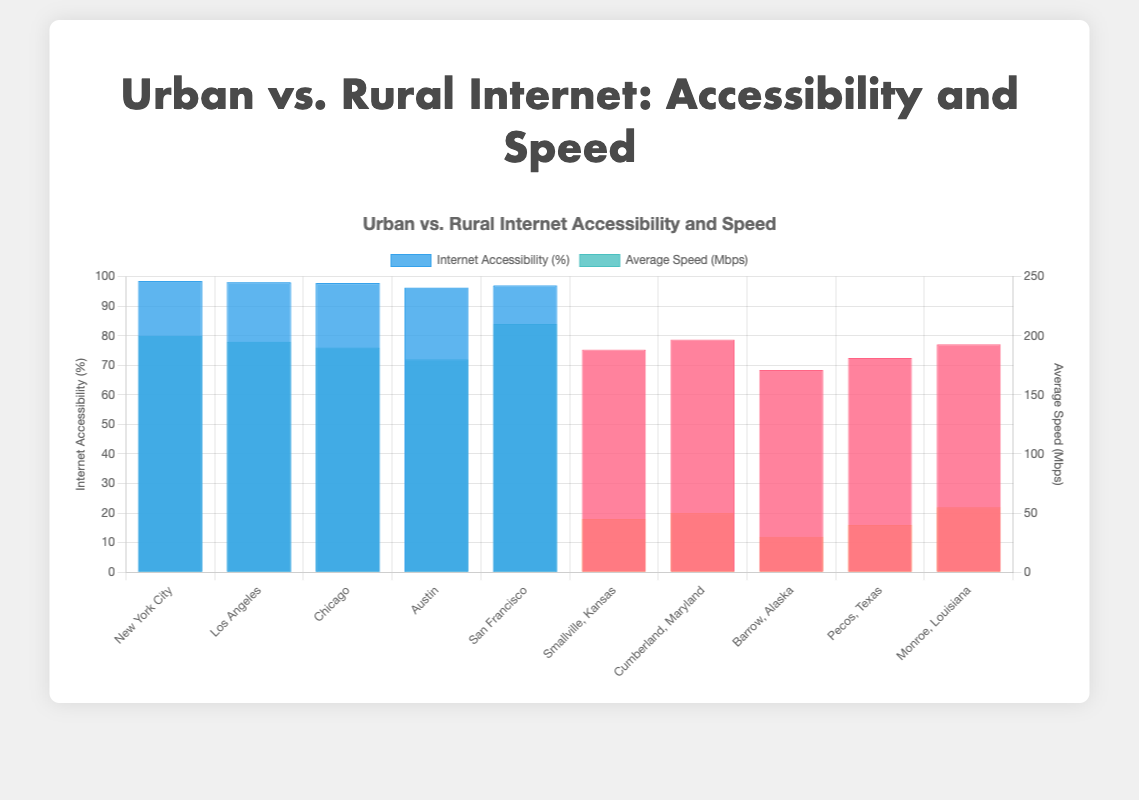Which region has the highest internet accessibility percentage? By examining the bar heights in the "Internet Accessibility (%)" dataset, the highest bar corresponds to New York City.
Answer: New York City What's the average internet speed for urban regions? To find the average speed, sum the speeds of all urban regions and divide by the number of these regions. The speeds are 200, 195, 190, 180, and 210. (200 + 195 + 190 + 180 + 210) / 5 = 975 / 5 = 195
Answer: 195 How much more accessible is internet in Los Angeles compared to Smallville, Kansas? Look at the heights of the bars representing internet accessibility for both regions. Los Angeles has 98.1% and Smallville has 75.3%. The difference is 98.1 - 75.3 = 22.8
Answer: 22.8 Which rural region has the highest average internet speed and what is that speed? Compare the bars under "Average Speed (Mbps)" for rural areas. The highest bar among the rural regions corresponds to Monroe, Louisiana at 55 Mbps.
Answer: Monroe, Louisiana, 55 What’s the difference in internet accessibility between the urban areas with the highest and lowest accessibility? Identify the highest and lowest bars under “Internet Accessibility (%)” for urban areas. The highest is New York City (98.5%) and the lowest is Austin (96.2%). Calculate the difference: 98.5 - 96.2 = 2.3
Answer: 2.3 Which region has the lowest average internet speed and what is it? Find the lowest bar under the "Average Speed (Mbps)" category. The smallest bar corresponds to Barrow, Alaska, with 30 Mbps.
Answer: Barrow, Alaska, 30 In which urban region is the speed of the internet the highest? Examine the heights of the bars for average speed in urban regions. The highest bar corresponds to San Francisco with 210 Mbps.
Answer: San Francisco What is the combined internet accessibility percentage of Chicago and Monroe, Louisiana? Add the internet accessibility percentages for Chicago (97.8%) and Monroe, Louisiana (77.1%). 97.8 + 77.1 = 174.9
Answer: 174.9 How does the internet accessibility in Pecos, Texas compare to Cumberland, Maryland? Look at the heights of the bars indicating internet accessibility for both regions. Pecos, Texas is at 72.5% and Cumberland, Maryland is at 78.7%. Pecos has lower accessibility.
Answer: Lower in Pecos What is the average internet accessibility percentage in rural areas? Sum the internet accessibility percentages for all rural regions and divide by the number of rural regions. (75.3 + 78.7 + 68.4 + 72.5 + 77.1) / 5 = 372 / 5 = 74.4
Answer: 74.4 